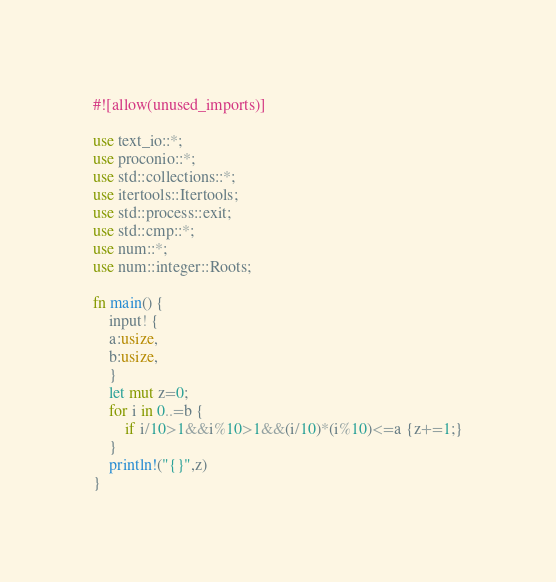Convert code to text. <code><loc_0><loc_0><loc_500><loc_500><_Rust_>#![allow(unused_imports)]

use text_io::*;
use proconio::*;
use std::collections::*;
use itertools::Itertools;
use std::process::exit;
use std::cmp::*;
use num::*;
use num::integer::Roots;

fn main() {
    input! {
    a:usize,
    b:usize,
    }
    let mut z=0;
    for i in 0..=b {
        if i/10>1&&i%10>1&&(i/10)*(i%10)<=a {z+=1;}
    }
    println!("{}",z)
}</code> 